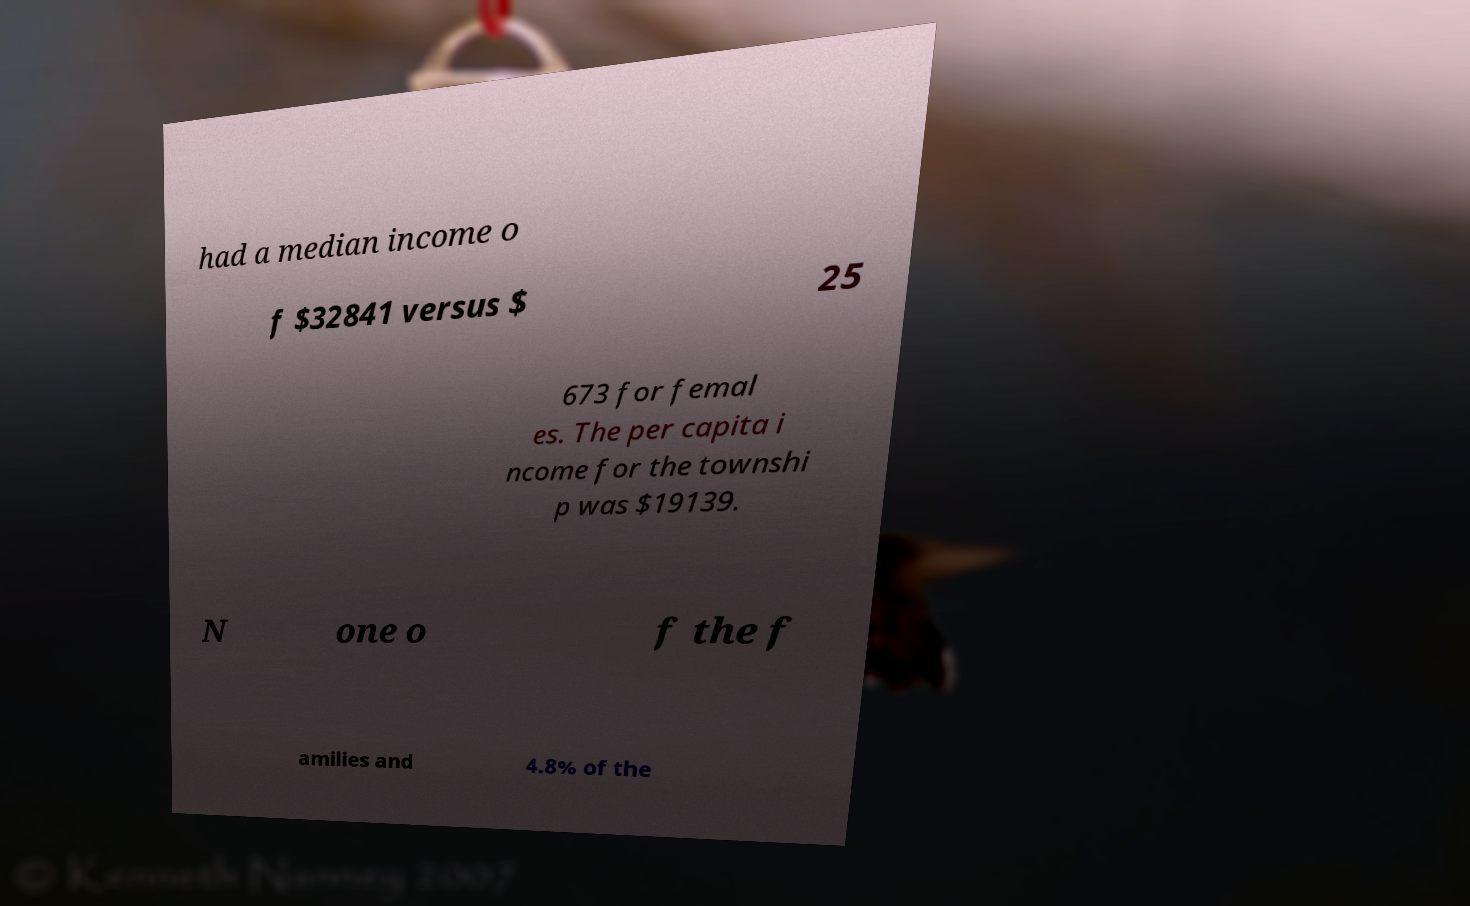Could you assist in decoding the text presented in this image and type it out clearly? had a median income o f $32841 versus $ 25 673 for femal es. The per capita i ncome for the townshi p was $19139. N one o f the f amilies and 4.8% of the 